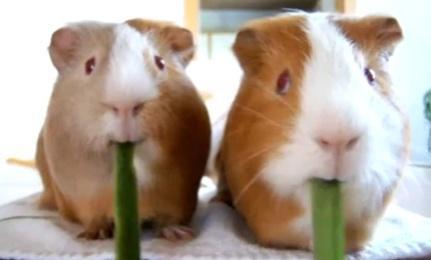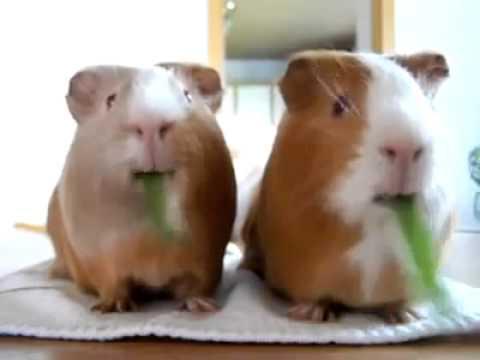The first image is the image on the left, the second image is the image on the right. Evaluate the accuracy of this statement regarding the images: "Two guinea pigs are chewing on the same item in each of the images.". Is it true? Answer yes or no. No. 